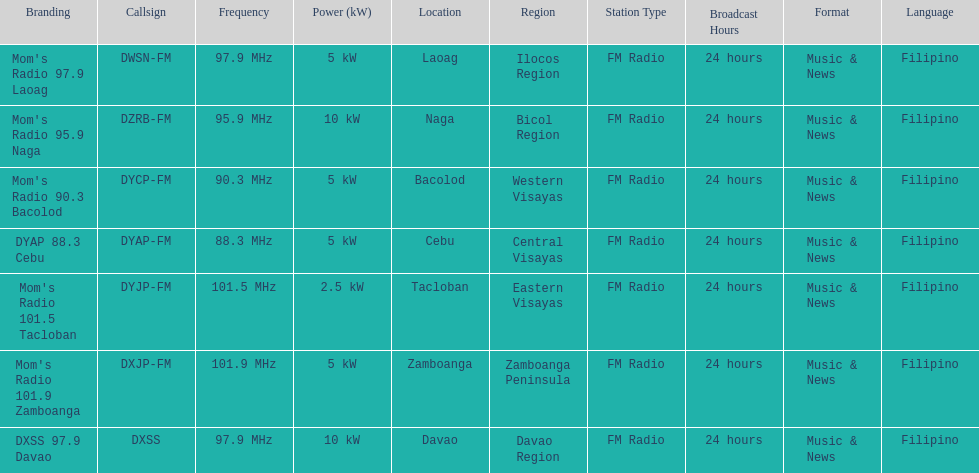How many kw was the radio in davao? 10 kW. 